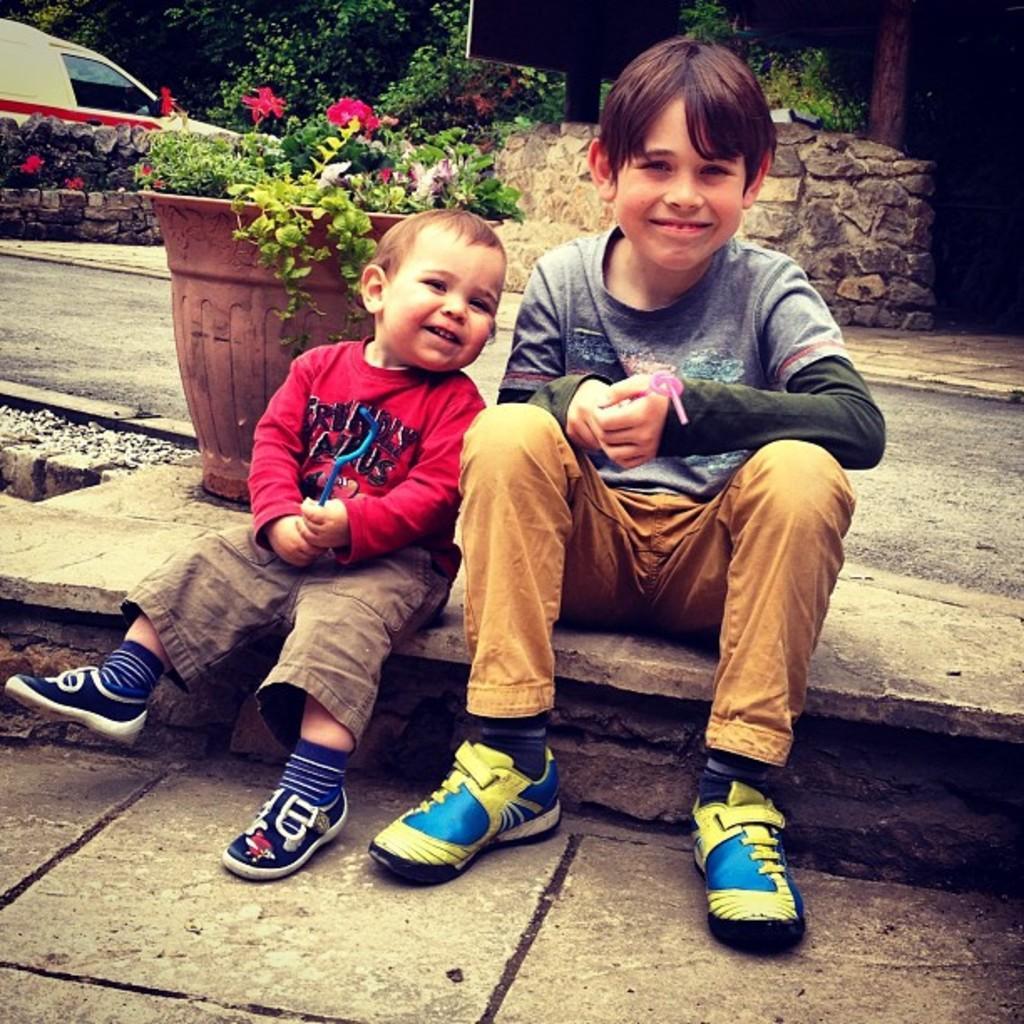Describe this image in one or two sentences. In this image I can see see two kids are sitting and smiling. In the background I can see a vehicle, flower pot, trees and other objects. 